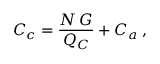Convert formula to latex. <formula><loc_0><loc_0><loc_500><loc_500>C _ { c } = \frac { N \, G } { Q _ { C } } + C _ { a } \, ,</formula> 